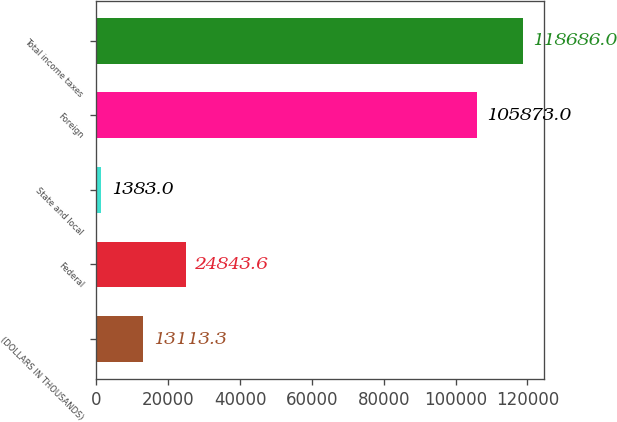<chart> <loc_0><loc_0><loc_500><loc_500><bar_chart><fcel>(DOLLARS IN THOUSANDS)<fcel>Federal<fcel>State and local<fcel>Foreign<fcel>Total income taxes<nl><fcel>13113.3<fcel>24843.6<fcel>1383<fcel>105873<fcel>118686<nl></chart> 